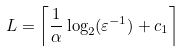Convert formula to latex. <formula><loc_0><loc_0><loc_500><loc_500>L = \left \lceil \frac { 1 } { \alpha } \log _ { 2 } ( \varepsilon ^ { - 1 } ) + c _ { 1 } \right \rceil</formula> 